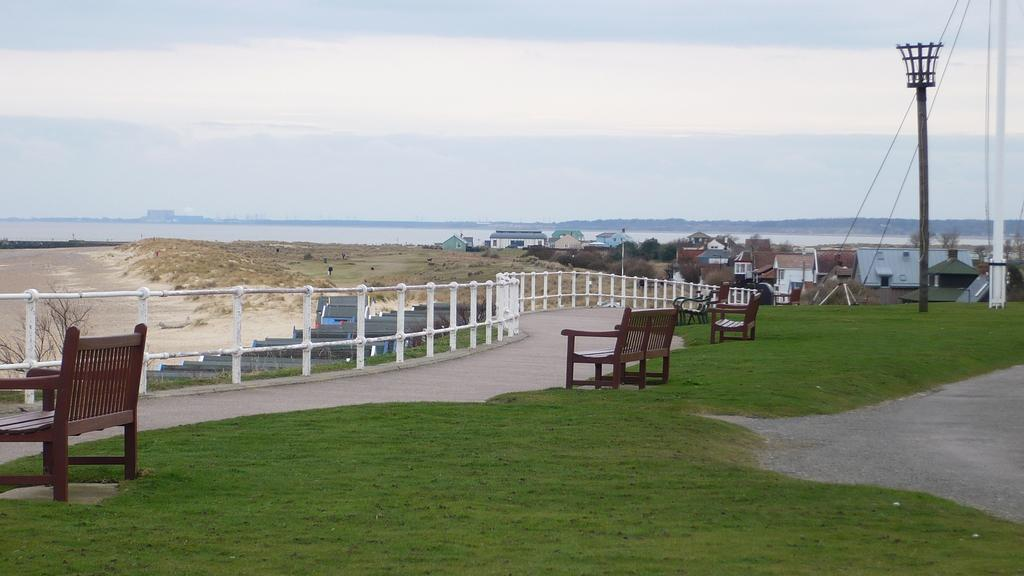What type of surface can be seen in the image? There is ground visible in the image. What type of vegetation is present in the image? There is grass in the image. What type of seating is available in the image? There are benches in the image. What type of structures are present in the image? There are poles, a railing, and buildings in the image. What type of natural elements are present in the image? There are trees and water visible in the background of the image. What part of the natural environment is visible in the image? The sky is visible in the background of the image. What type of store can be seen in the image? There is no store present in the image. What type of activity is taking place in the image? The image does not depict any specific activity; it shows a scene with various elements such as ground, grass, benches, poles, railing, buildings, trees, water, and sky. 